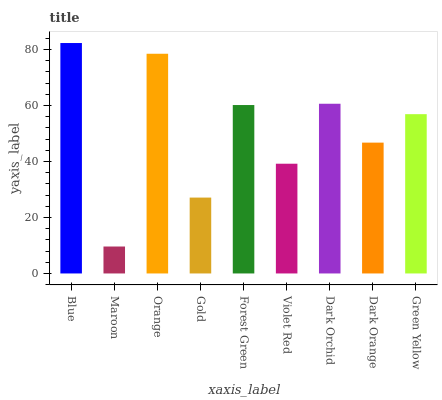Is Maroon the minimum?
Answer yes or no. Yes. Is Blue the maximum?
Answer yes or no. Yes. Is Orange the minimum?
Answer yes or no. No. Is Orange the maximum?
Answer yes or no. No. Is Orange greater than Maroon?
Answer yes or no. Yes. Is Maroon less than Orange?
Answer yes or no. Yes. Is Maroon greater than Orange?
Answer yes or no. No. Is Orange less than Maroon?
Answer yes or no. No. Is Green Yellow the high median?
Answer yes or no. Yes. Is Green Yellow the low median?
Answer yes or no. Yes. Is Forest Green the high median?
Answer yes or no. No. Is Dark Orange the low median?
Answer yes or no. No. 